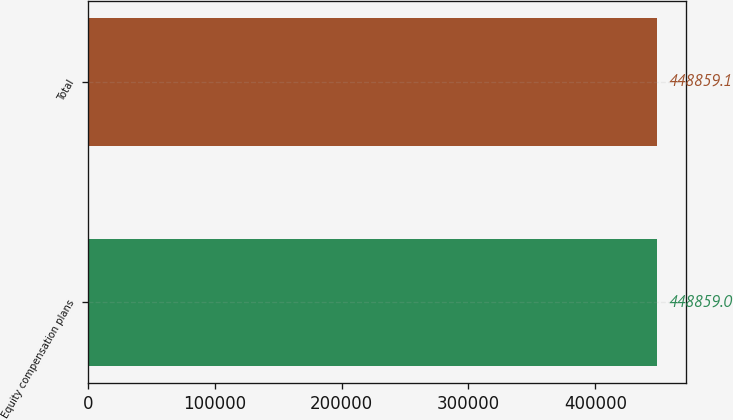<chart> <loc_0><loc_0><loc_500><loc_500><bar_chart><fcel>Equity compensation plans<fcel>Total<nl><fcel>448859<fcel>448859<nl></chart> 